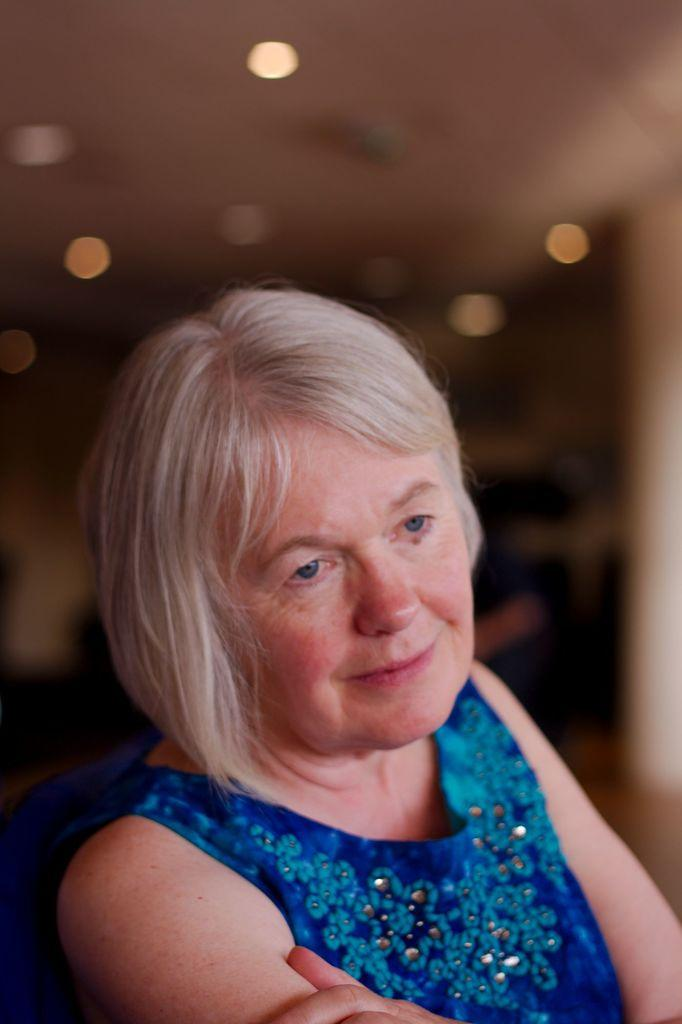Who is present in the image? There is a woman in the image. What is the woman's facial expression? The woman is smiling. Can you describe the background of the image? The background of the image appears blurry. How many planes can be seen flying in the background of the image? There are no planes visible in the image; the background appears blurry. 